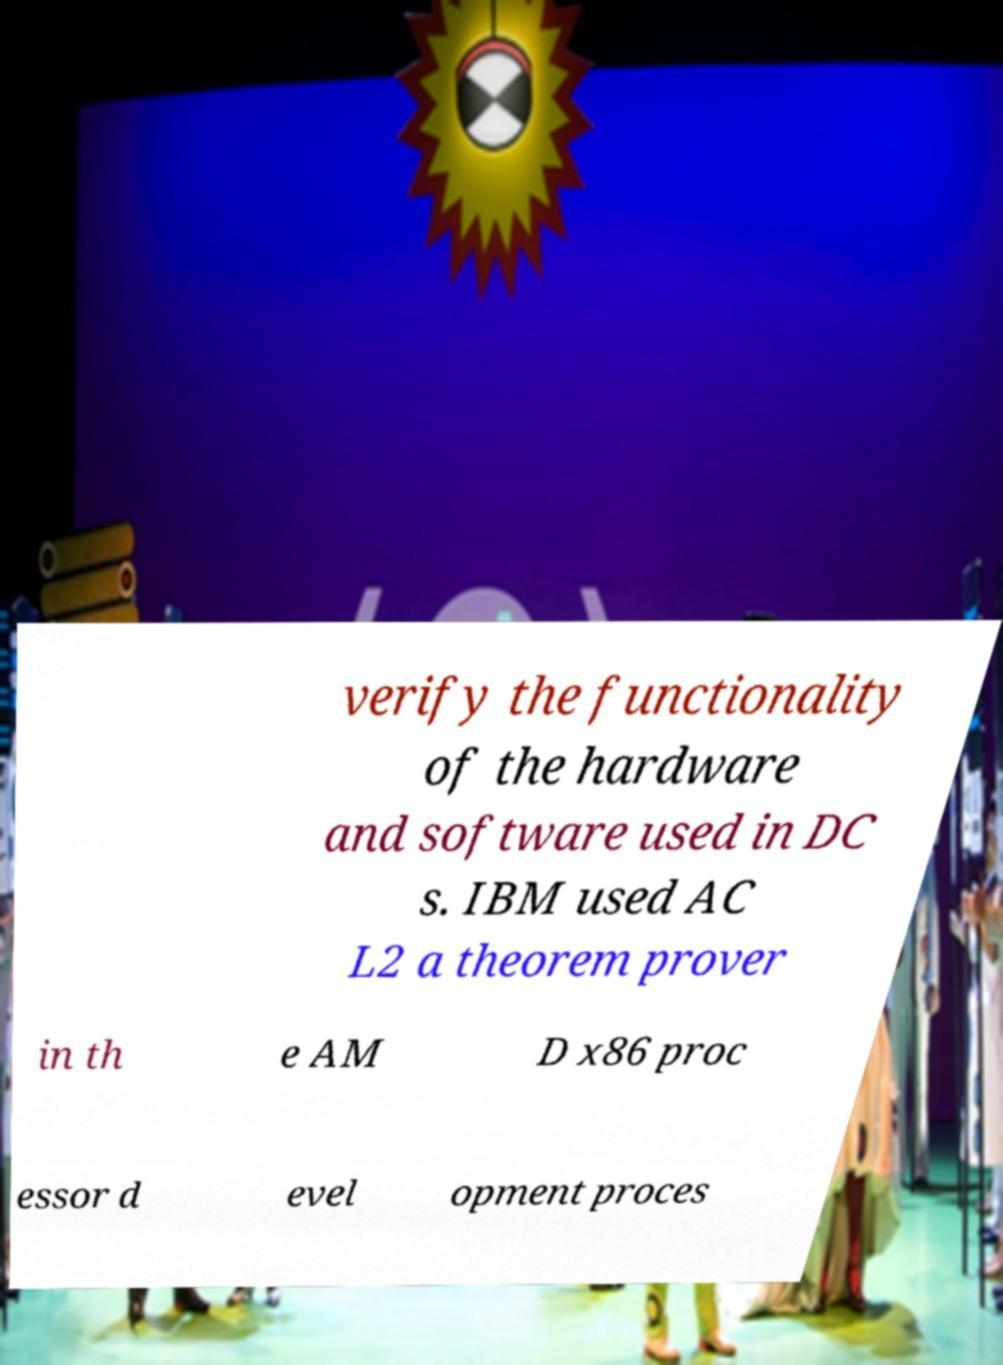Can you read and provide the text displayed in the image?This photo seems to have some interesting text. Can you extract and type it out for me? verify the functionality of the hardware and software used in DC s. IBM used AC L2 a theorem prover in th e AM D x86 proc essor d evel opment proces 